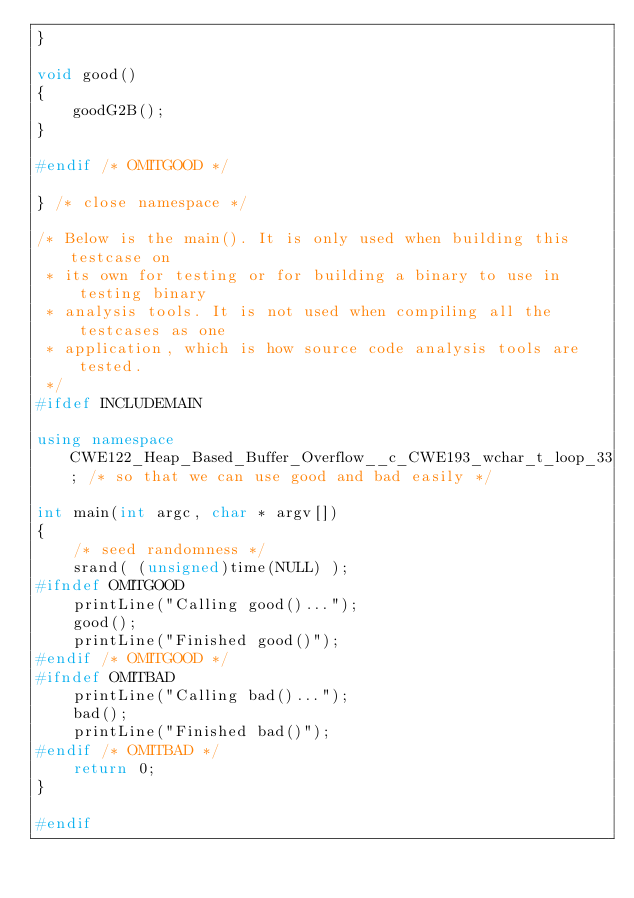Convert code to text. <code><loc_0><loc_0><loc_500><loc_500><_C++_>}

void good()
{
    goodG2B();
}

#endif /* OMITGOOD */

} /* close namespace */

/* Below is the main(). It is only used when building this testcase on
 * its own for testing or for building a binary to use in testing binary
 * analysis tools. It is not used when compiling all the testcases as one
 * application, which is how source code analysis tools are tested.
 */
#ifdef INCLUDEMAIN

using namespace CWE122_Heap_Based_Buffer_Overflow__c_CWE193_wchar_t_loop_33; /* so that we can use good and bad easily */

int main(int argc, char * argv[])
{
    /* seed randomness */
    srand( (unsigned)time(NULL) );
#ifndef OMITGOOD
    printLine("Calling good()...");
    good();
    printLine("Finished good()");
#endif /* OMITGOOD */
#ifndef OMITBAD
    printLine("Calling bad()...");
    bad();
    printLine("Finished bad()");
#endif /* OMITBAD */
    return 0;
}

#endif
</code> 